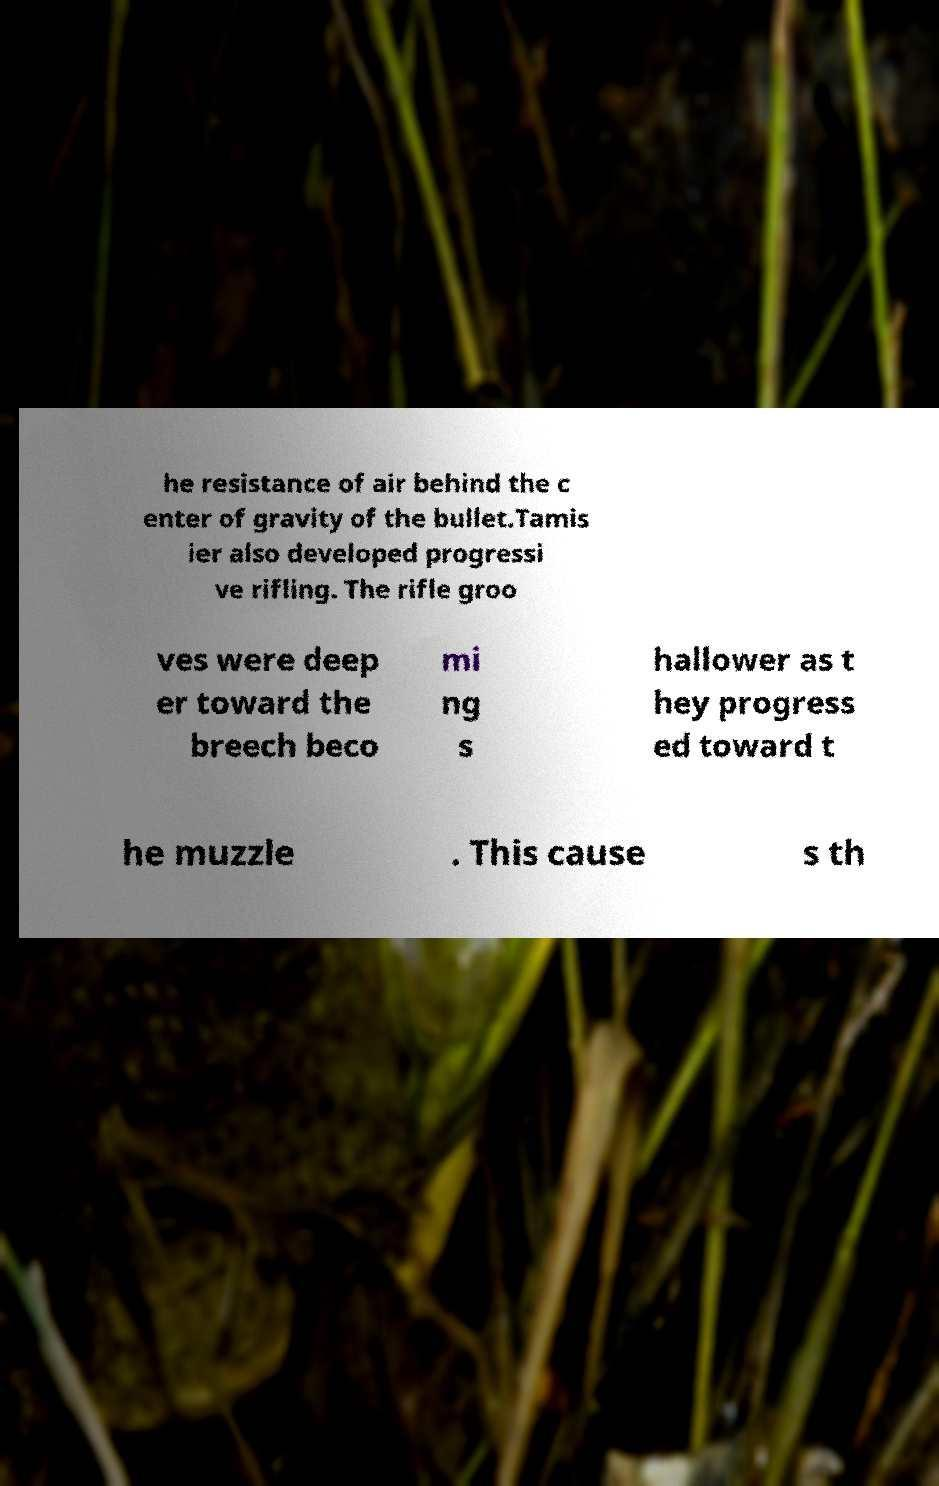There's text embedded in this image that I need extracted. Can you transcribe it verbatim? he resistance of air behind the c enter of gravity of the bullet.Tamis ier also developed progressi ve rifling. The rifle groo ves were deep er toward the breech beco mi ng s hallower as t hey progress ed toward t he muzzle . This cause s th 